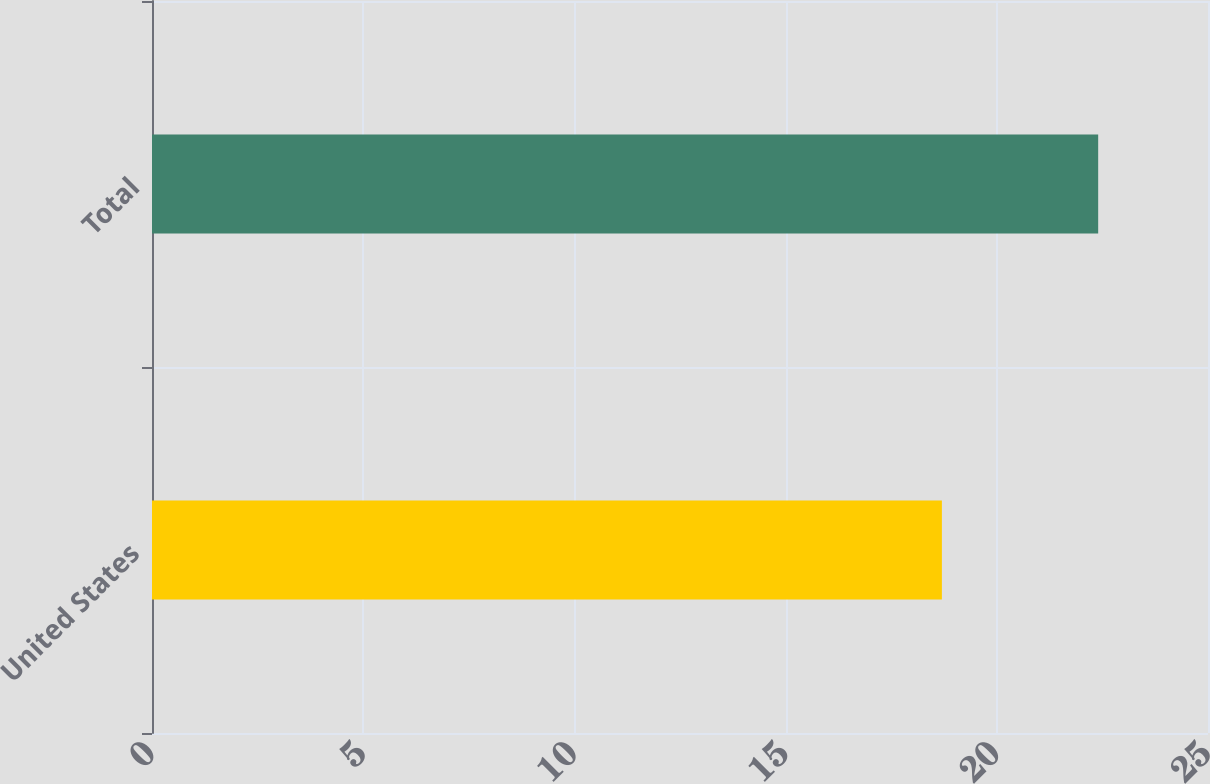<chart> <loc_0><loc_0><loc_500><loc_500><bar_chart><fcel>United States<fcel>Total<nl><fcel>18.7<fcel>22.4<nl></chart> 